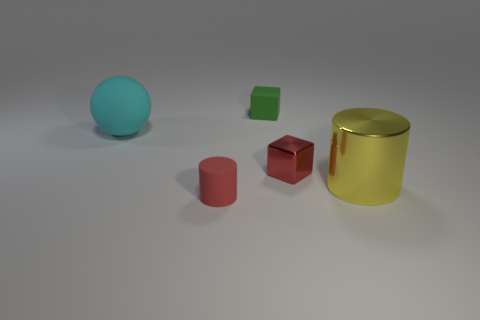Add 4 tiny cubes. How many objects exist? 9 Subtract all cylinders. How many objects are left? 3 Add 1 large matte balls. How many large matte balls exist? 2 Subtract 0 blue blocks. How many objects are left? 5 Subtract all tiny gray metal blocks. Subtract all green rubber cubes. How many objects are left? 4 Add 3 tiny red cubes. How many tiny red cubes are left? 4 